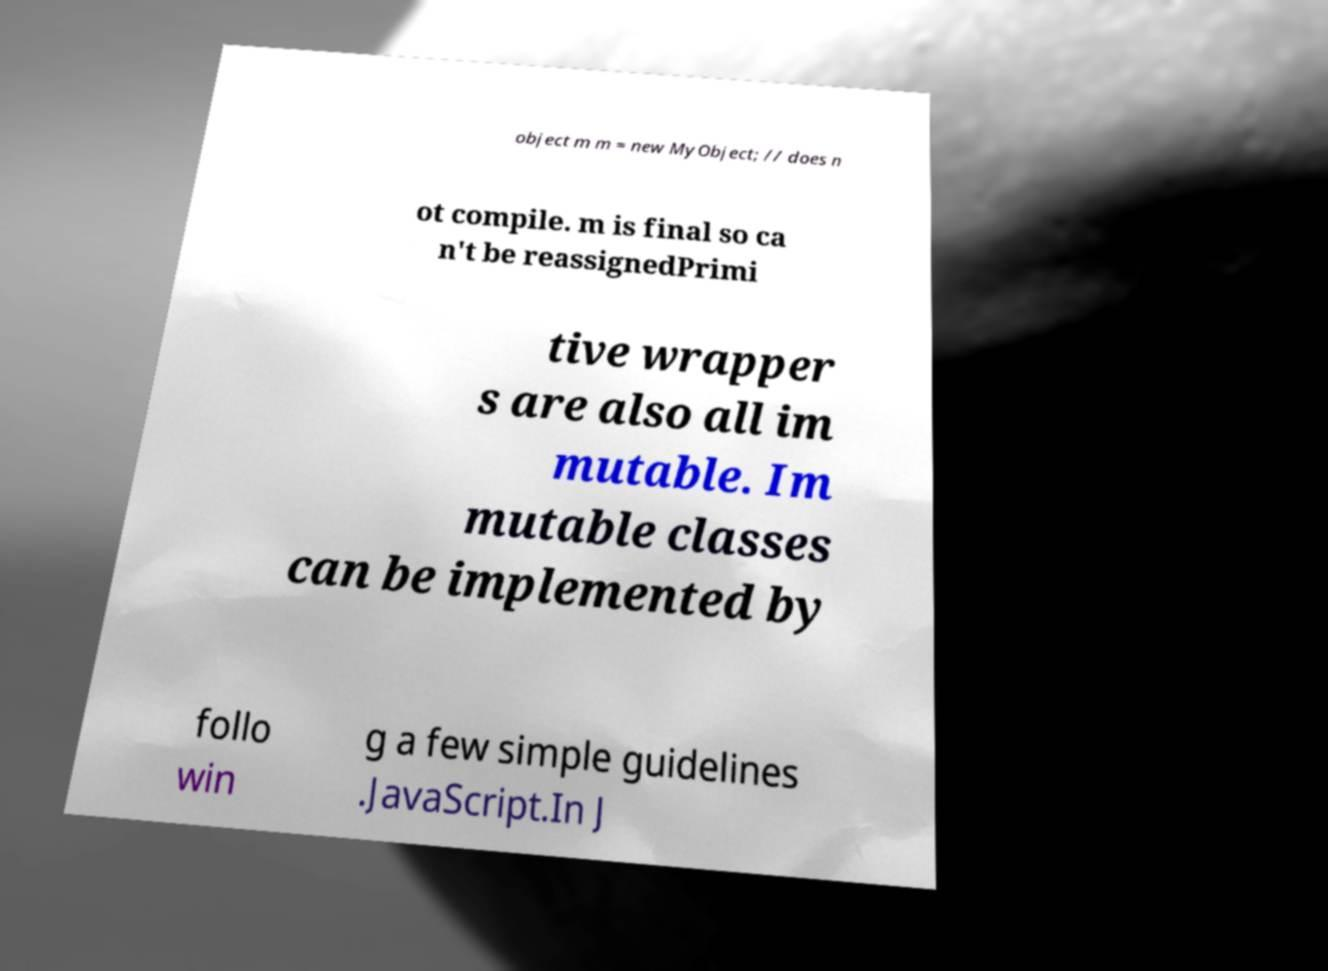Can you accurately transcribe the text from the provided image for me? object m m = new MyObject; // does n ot compile. m is final so ca n't be reassignedPrimi tive wrapper s are also all im mutable. Im mutable classes can be implemented by follo win g a few simple guidelines .JavaScript.In J 